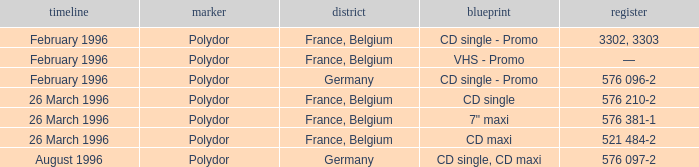Tell me the region for catalog of 576 096-2 Germany. 